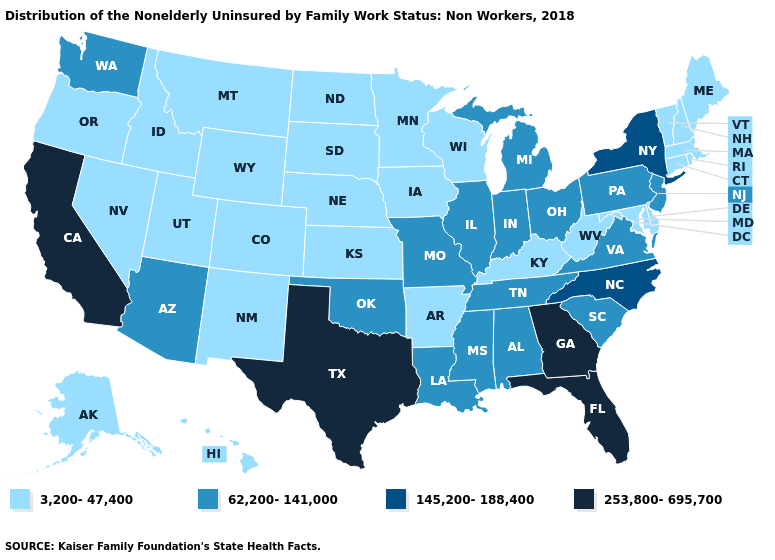What is the value of Massachusetts?
Answer briefly. 3,200-47,400. Name the states that have a value in the range 3,200-47,400?
Write a very short answer. Alaska, Arkansas, Colorado, Connecticut, Delaware, Hawaii, Idaho, Iowa, Kansas, Kentucky, Maine, Maryland, Massachusetts, Minnesota, Montana, Nebraska, Nevada, New Hampshire, New Mexico, North Dakota, Oregon, Rhode Island, South Dakota, Utah, Vermont, West Virginia, Wisconsin, Wyoming. Among the states that border Utah , does Nevada have the lowest value?
Answer briefly. Yes. Name the states that have a value in the range 145,200-188,400?
Give a very brief answer. New York, North Carolina. Name the states that have a value in the range 145,200-188,400?
Short answer required. New York, North Carolina. Name the states that have a value in the range 62,200-141,000?
Quick response, please. Alabama, Arizona, Illinois, Indiana, Louisiana, Michigan, Mississippi, Missouri, New Jersey, Ohio, Oklahoma, Pennsylvania, South Carolina, Tennessee, Virginia, Washington. Does the first symbol in the legend represent the smallest category?
Give a very brief answer. Yes. What is the value of California?
Quick response, please. 253,800-695,700. How many symbols are there in the legend?
Short answer required. 4. What is the highest value in states that border Florida?
Short answer required. 253,800-695,700. What is the highest value in states that border Colorado?
Give a very brief answer. 62,200-141,000. Name the states that have a value in the range 62,200-141,000?
Short answer required. Alabama, Arizona, Illinois, Indiana, Louisiana, Michigan, Mississippi, Missouri, New Jersey, Ohio, Oklahoma, Pennsylvania, South Carolina, Tennessee, Virginia, Washington. How many symbols are there in the legend?
Concise answer only. 4. What is the value of North Carolina?
Answer briefly. 145,200-188,400. What is the value of Maryland?
Write a very short answer. 3,200-47,400. 